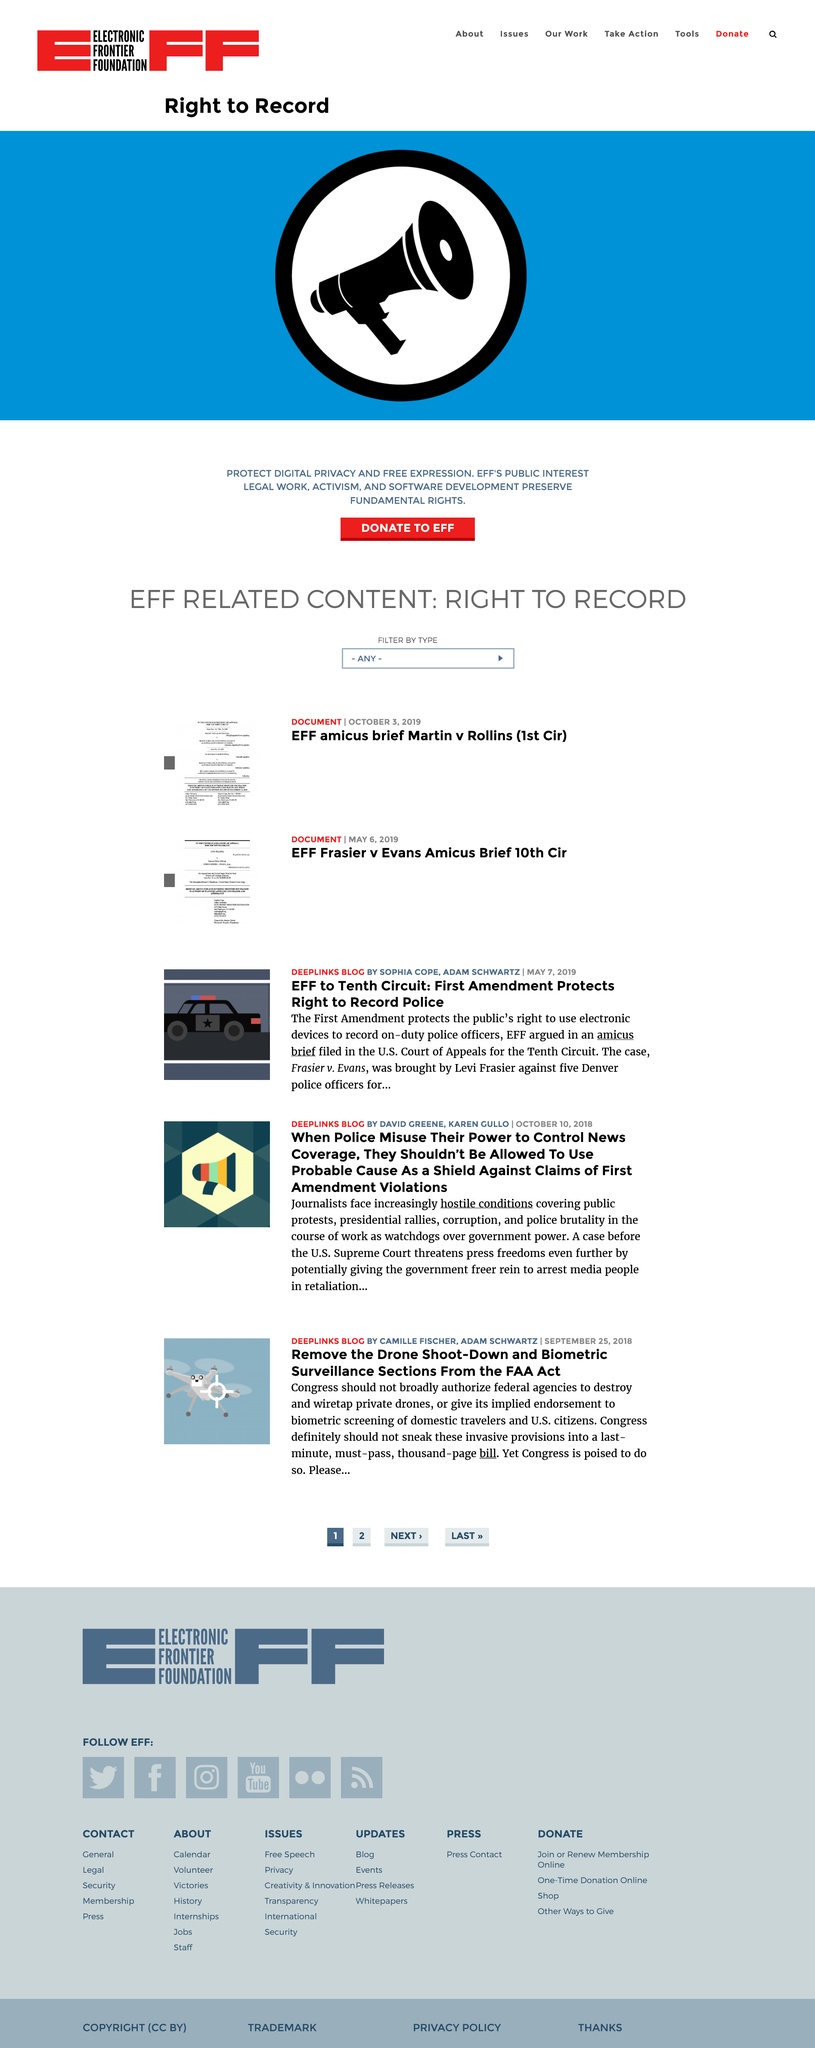Highlight a few significant elements in this photo. As many as five authors were credited in writing the three articles. Journalists who cover public protests often face hostile conditions that can put their safety at risk. The articles “EFF To Tenth Circuit: First amendment Protects Right to Record Police” and “Remove the Drone Shoot-Down and Biometric Surveillance Sections from the FAA Act” were written in part by Adam Schwartz. 